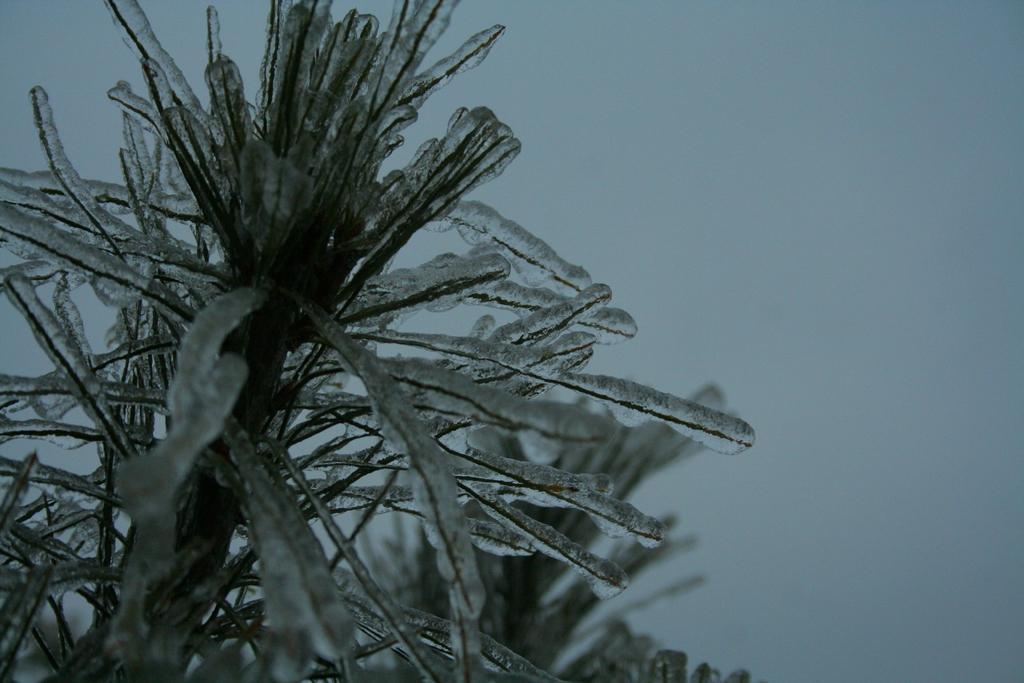How would you summarize this image in a sentence or two? In this image we can see a plant with snow and we can see the white background. 